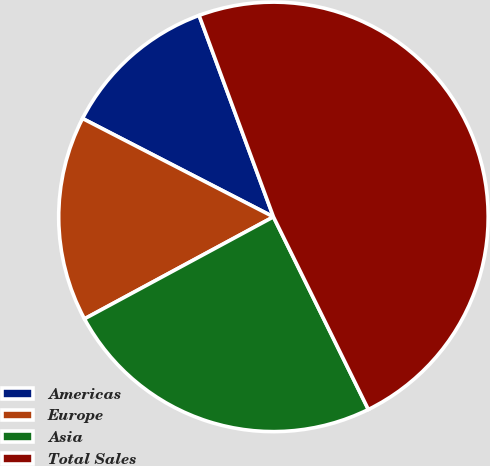Convert chart to OTSL. <chart><loc_0><loc_0><loc_500><loc_500><pie_chart><fcel>Americas<fcel>Europe<fcel>Asia<fcel>Total Sales<nl><fcel>11.8%<fcel>15.45%<fcel>24.41%<fcel>48.34%<nl></chart> 